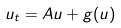<formula> <loc_0><loc_0><loc_500><loc_500>u _ { t } = A u + g ( u )</formula> 